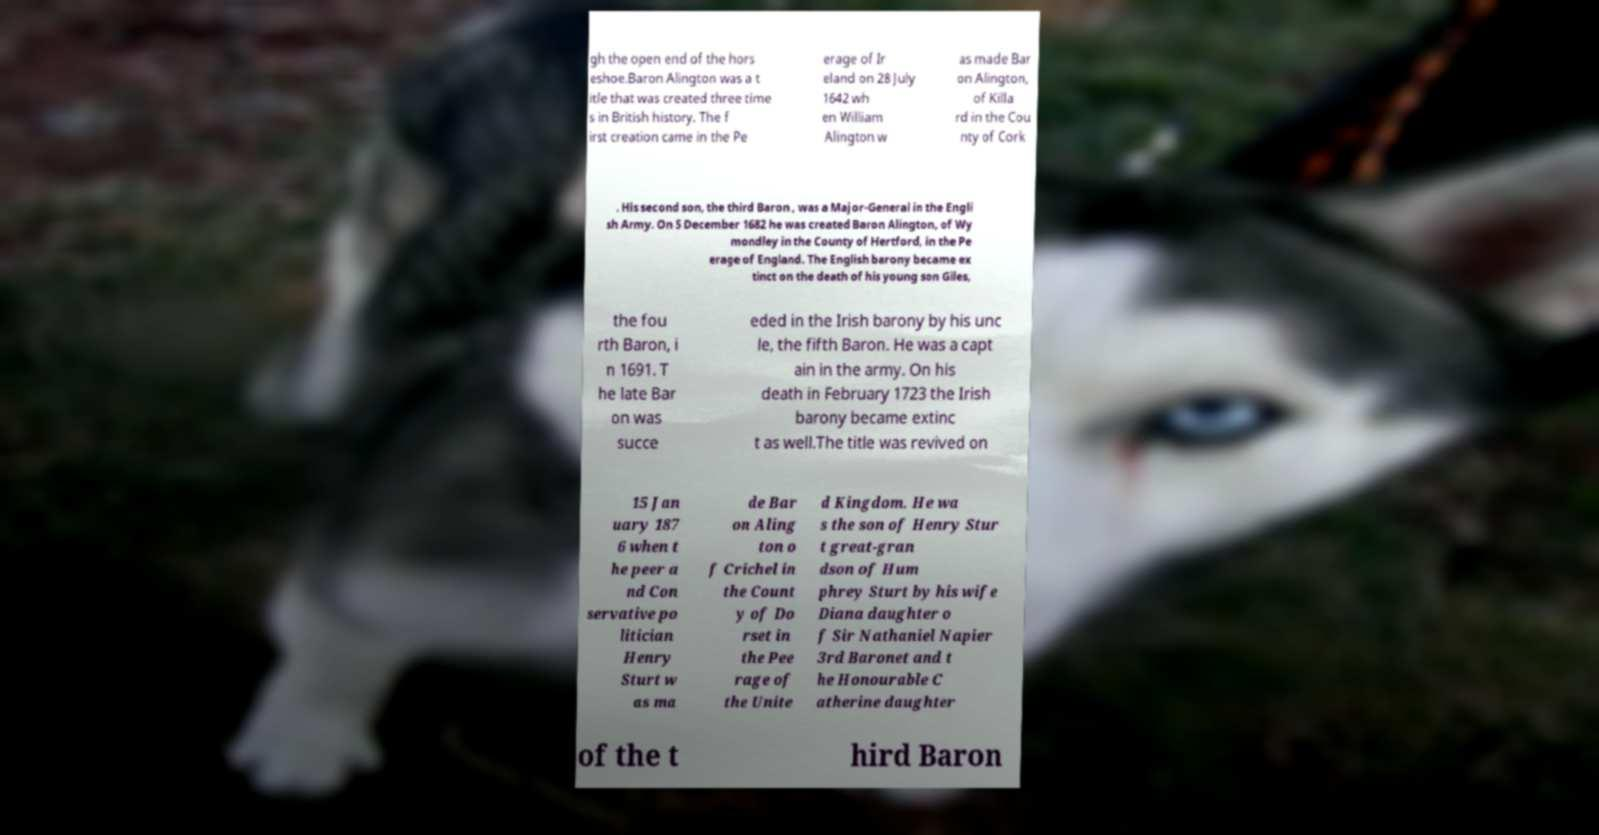I need the written content from this picture converted into text. Can you do that? gh the open end of the hors eshoe.Baron Alington was a t itle that was created three time s in British history. The f irst creation came in the Pe erage of Ir eland on 28 July 1642 wh en William Alington w as made Bar on Alington, of Killa rd in the Cou nty of Cork . His second son, the third Baron , was a Major-General in the Engli sh Army. On 5 December 1682 he was created Baron Alington, of Wy mondley in the County of Hertford, in the Pe erage of England. The English barony became ex tinct on the death of his young son Giles, the fou rth Baron, i n 1691. T he late Bar on was succe eded in the Irish barony by his unc le, the fifth Baron. He was a capt ain in the army. On his death in February 1723 the Irish barony became extinc t as well.The title was revived on 15 Jan uary 187 6 when t he peer a nd Con servative po litician Henry Sturt w as ma de Bar on Aling ton o f Crichel in the Count y of Do rset in the Pee rage of the Unite d Kingdom. He wa s the son of Henry Stur t great-gran dson of Hum phrey Sturt by his wife Diana daughter o f Sir Nathaniel Napier 3rd Baronet and t he Honourable C atherine daughter of the t hird Baron 